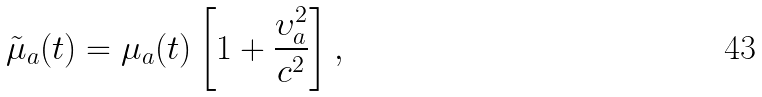Convert formula to latex. <formula><loc_0><loc_0><loc_500><loc_500>\tilde { \mu } _ { a } ( t ) = \mu _ { a } ( t ) \left [ 1 + \frac { \upsilon _ { a } ^ { 2 } } { c ^ { 2 } } \right ] ,</formula> 